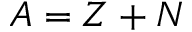Convert formula to latex. <formula><loc_0><loc_0><loc_500><loc_500>A = Z + N</formula> 